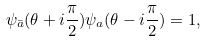Convert formula to latex. <formula><loc_0><loc_0><loc_500><loc_500>\psi _ { \bar { a } } ( \theta + i \frac { \pi } { 2 } ) \psi _ { a } ( \theta - i \frac { \pi } { 2 } ) = 1 ,</formula> 